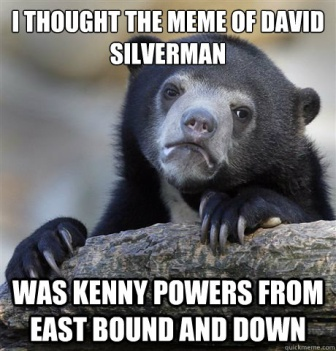What is this photo about? The image shows a black bear resting its head on a tree branch. The bear's expression appears slightly puzzled or curious, as it looks directly at the camera. Overlaying the image is humorous white text that reads, "I thought the meme of David Silverman was Kenny Powers from East Bound and Down." This text implies a mix-up between two individuals, adding a layer of humor to the bear’s comical expression. The blurred background emphasizes the bear, making it the focal point of the image. This meme uses the bear's expression to complement the humorous text, creating an amusing and relatable internet meme. 